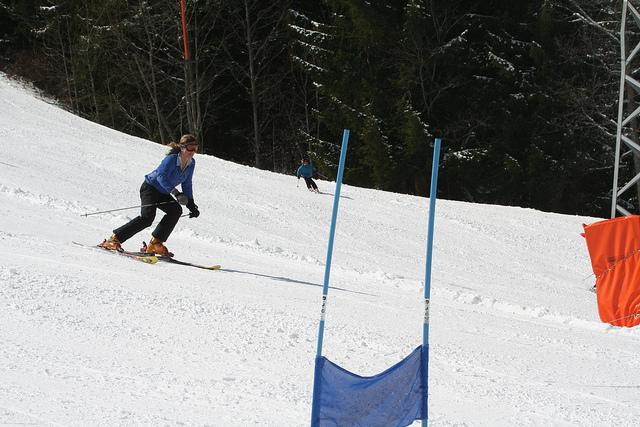Is she on a ski slope?
Keep it brief. Yes. What is she doing?
Quick response, please. Skiing. What color is the flag closest to the camera?
Quick response, please. Blue. Is the woman a beginning skier?
Quick response, please. No. How many nets are there?
Concise answer only. 2. 